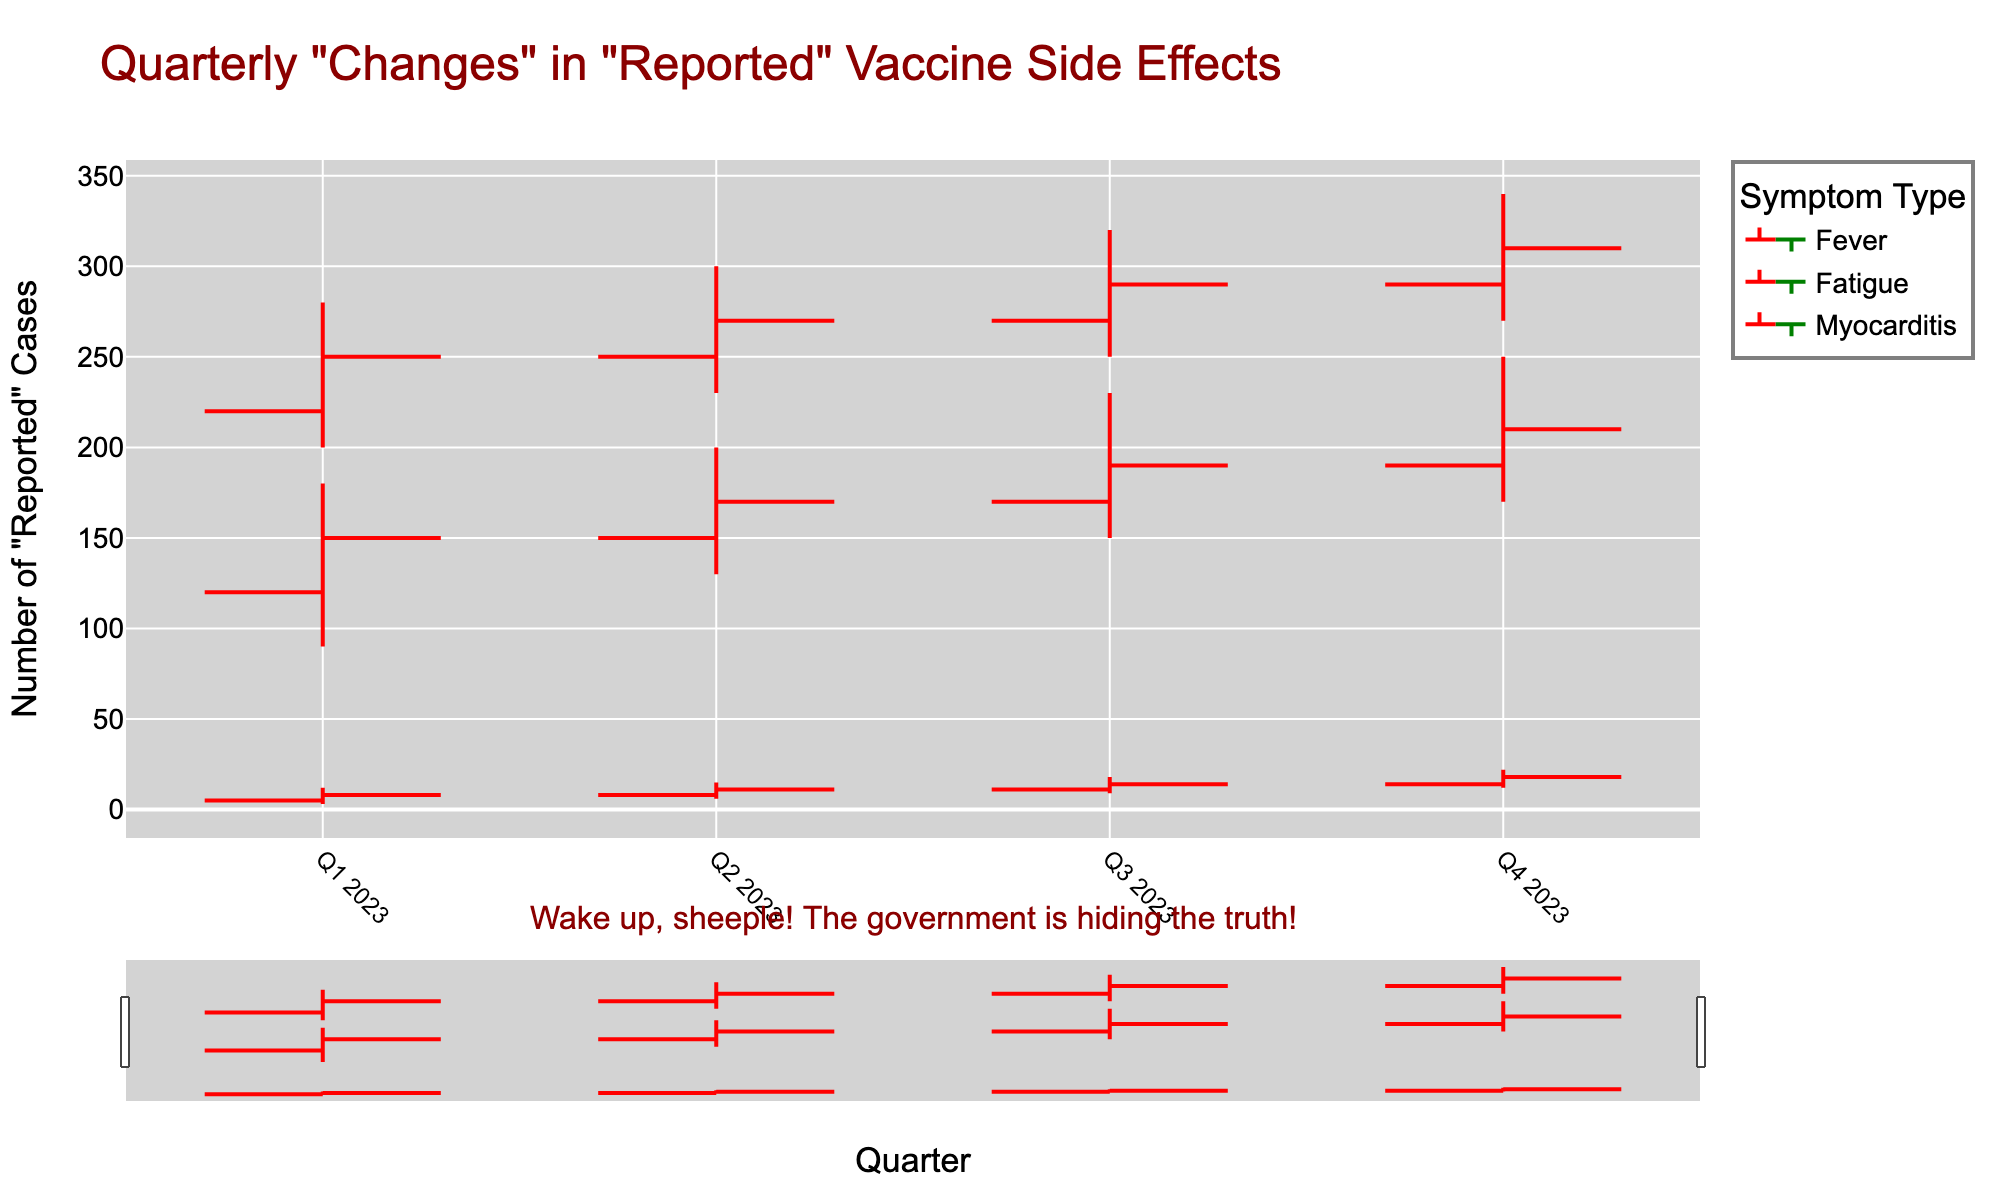What's the title of the figure? The title is usually displayed prominently at the top of the figure. In this case, the title reads, 'Quarterly "Changes" in "Reported" Vaccine Side Effects.'
Answer: Quarterly "Changes" in "Reported" Vaccine Side Effects What color are the lines when the number of reported cases increases? The increasing lines are colored red, indicating the number of reported cases has risen.
Answer: red Which symptom type has the highest reported cases in Q4 2023? By examining the 'High' values for Q4 2023 across all symptoms, Fatigue has the highest value at 340 cases.
Answer: Fatigue How did the number of reported cases for Fever change between Q1 2023 and Q2 2023? To determine the change, we look at the 'Close' value for Q1 2023 (150) and Q2 2023 (170). The difference is 170 - 150 = 20.
Answer: Increased by 20 Which symptom experienced the most decrease in reported cases during any quarter? By examining the 'Low' value changes, Fever decreased from 90 in Q1 2023 to 150 in Q3 2023, a difference of 60.
Answer: Fever in Q1 to Q3 2023 What's the average number of high reported cases for Myocarditis during 2023? The 'High' values for Myocarditis across the quarters are 12, 15, 18, and 22. The average is (12 + 15 + 18 + 22) / 4 = 16.75.
Answer: 16.75 Between which two consecutive quarters did Fatigue see the highest increase in the 'Open' value? For Fatigue, the 'Open' values are 220 (Q1), 250 (Q2), 270 (Q3), and 290 (Q4). The highest increase is from Q1 (220) to Q2 (250), a difference of 30.
Answer: Q1 to Q2 Did Myocarditis ever report more than 20 cases in any single quarter? The 'High' value for Myocarditis in Q4 2023 is 22, which exceeds 20.
Answer: Yes Which symptom had the smallest range in 'Low' values across all quarters? The ranges for 'Low' values are Fever: 40, Fatigue: 70, Myocarditis: 9. Myocarditis has the smallest range.
Answer: Myocarditis What's the total 'Close' value for Fatigue in all quarters of 2023? The 'Close' values for Fatigue are 250, 270, 290, and 310. The total is 250 + 270 + 290 + 310 = 1120.
Answer: 1120 